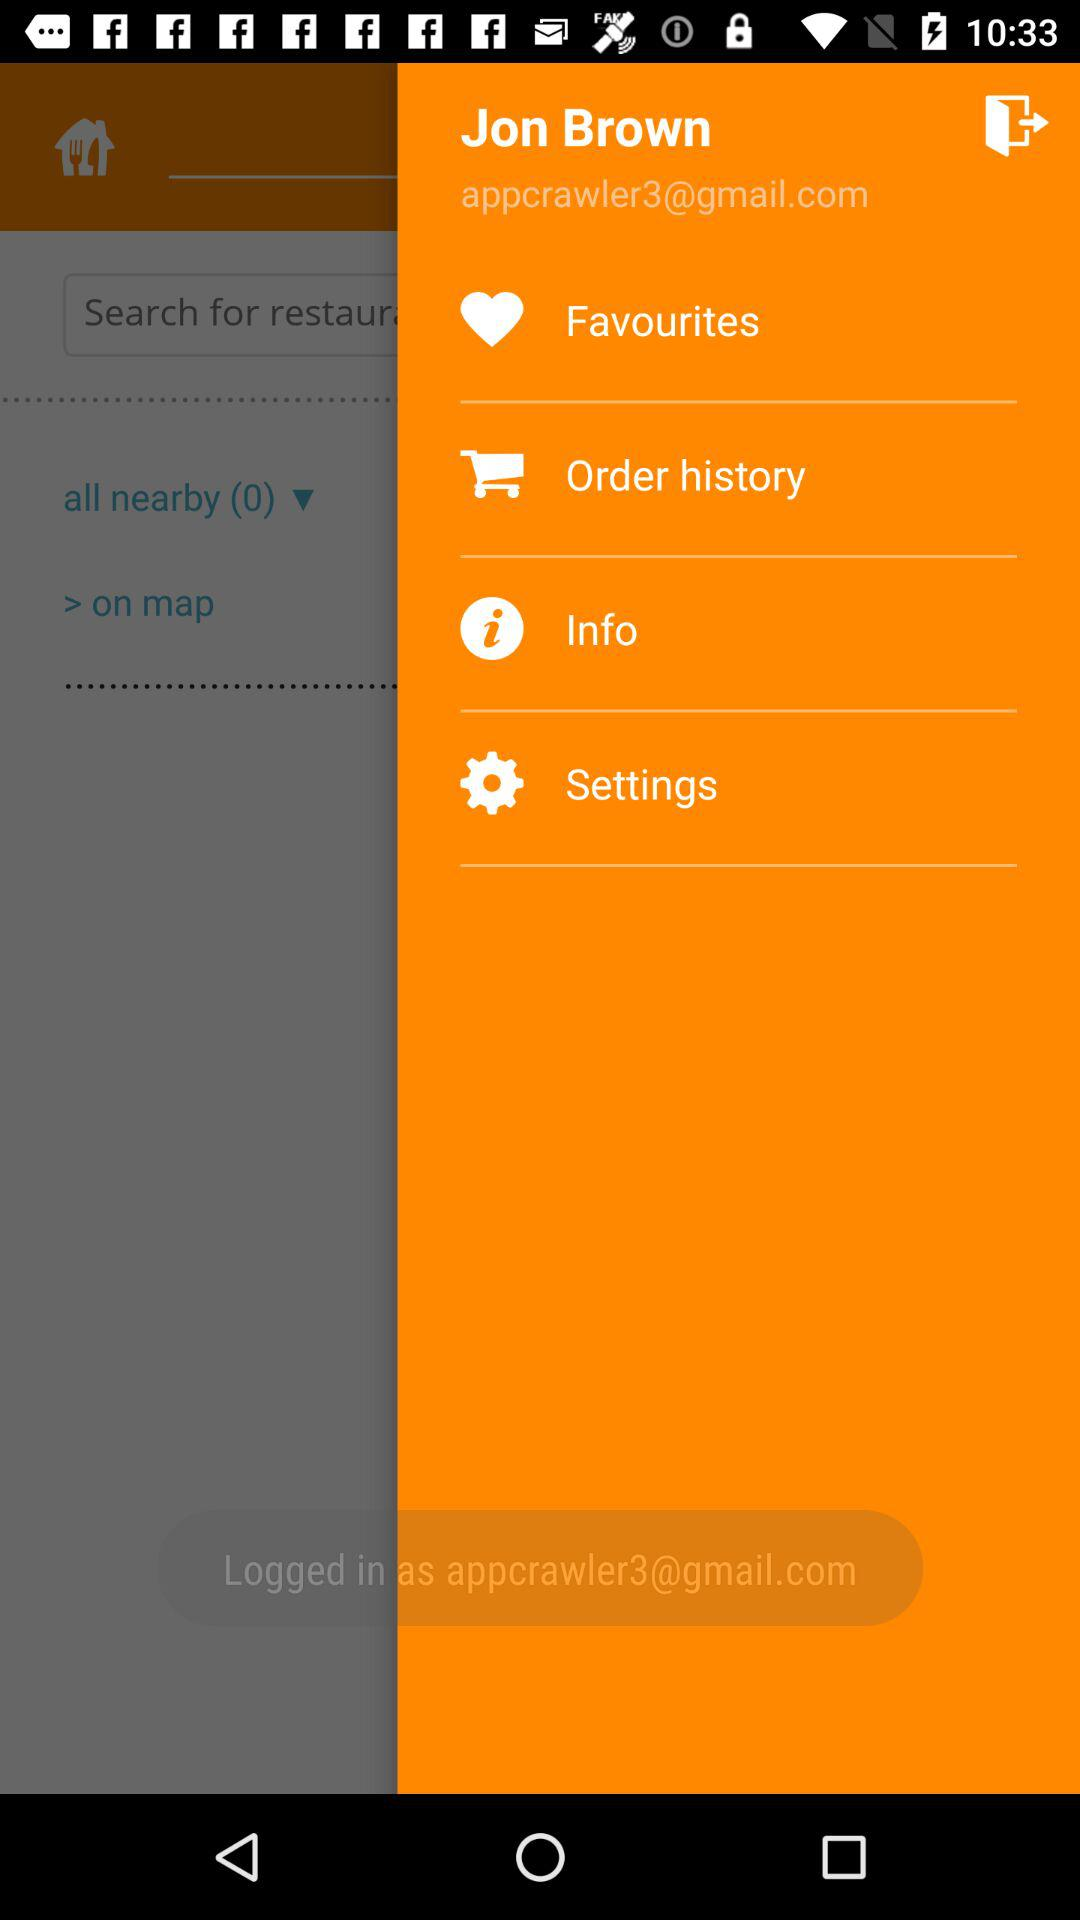What is the user name? The user name is Jon Brown. 